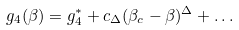<formula> <loc_0><loc_0><loc_500><loc_500>g _ { 4 } ( \beta ) = g _ { 4 } ^ { * } + c _ { \Delta } ( \beta _ { c } - \beta ) ^ { \Delta } + \dots</formula> 